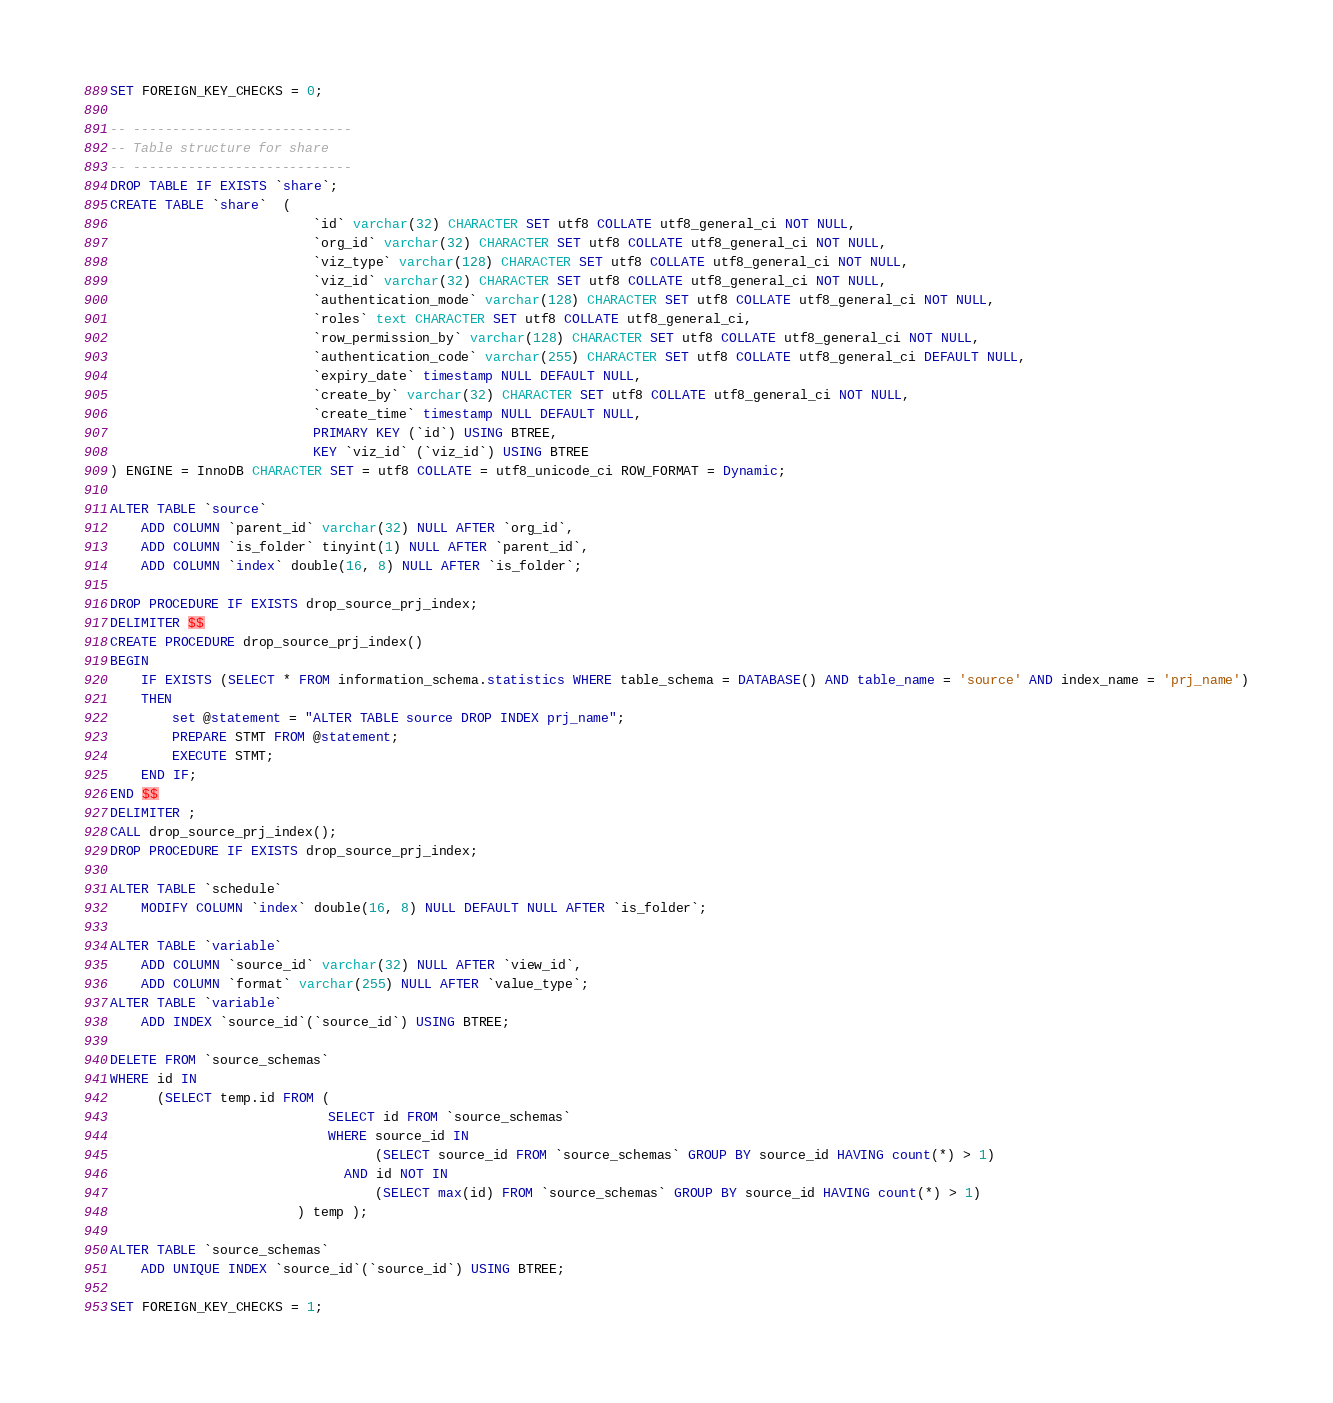<code> <loc_0><loc_0><loc_500><loc_500><_SQL_>SET FOREIGN_KEY_CHECKS = 0;

-- ----------------------------
-- Table structure for share
-- ----------------------------
DROP TABLE IF EXISTS `share`;
CREATE TABLE `share`  (
                          `id` varchar(32) CHARACTER SET utf8 COLLATE utf8_general_ci NOT NULL,
                          `org_id` varchar(32) CHARACTER SET utf8 COLLATE utf8_general_ci NOT NULL,
                          `viz_type` varchar(128) CHARACTER SET utf8 COLLATE utf8_general_ci NOT NULL,
                          `viz_id` varchar(32) CHARACTER SET utf8 COLLATE utf8_general_ci NOT NULL,
                          `authentication_mode` varchar(128) CHARACTER SET utf8 COLLATE utf8_general_ci NOT NULL,
                          `roles` text CHARACTER SET utf8 COLLATE utf8_general_ci,
                          `row_permission_by` varchar(128) CHARACTER SET utf8 COLLATE utf8_general_ci NOT NULL,
                          `authentication_code` varchar(255) CHARACTER SET utf8 COLLATE utf8_general_ci DEFAULT NULL,
                          `expiry_date` timestamp NULL DEFAULT NULL,
                          `create_by` varchar(32) CHARACTER SET utf8 COLLATE utf8_general_ci NOT NULL,
                          `create_time` timestamp NULL DEFAULT NULL,
                          PRIMARY KEY (`id`) USING BTREE,
                          KEY `viz_id` (`viz_id`) USING BTREE
) ENGINE = InnoDB CHARACTER SET = utf8 COLLATE = utf8_unicode_ci ROW_FORMAT = Dynamic;

ALTER TABLE `source`
    ADD COLUMN `parent_id` varchar(32) NULL AFTER `org_id`,
    ADD COLUMN `is_folder` tinyint(1) NULL AFTER `parent_id`,
    ADD COLUMN `index` double(16, 8) NULL AFTER `is_folder`;

DROP PROCEDURE IF EXISTS drop_source_prj_index;
DELIMITER $$
CREATE PROCEDURE drop_source_prj_index()
BEGIN
	IF EXISTS (SELECT * FROM information_schema.statistics WHERE table_schema = DATABASE() AND table_name = 'source' AND index_name = 'prj_name')
	THEN
	    set @statement = "ALTER TABLE source DROP INDEX prj_name";
        PREPARE STMT FROM @statement;
        EXECUTE STMT;
    END IF;
END $$
DELIMITER ;
CALL drop_source_prj_index();
DROP PROCEDURE IF EXISTS drop_source_prj_index;

ALTER TABLE `schedule`
    MODIFY COLUMN `index` double(16, 8) NULL DEFAULT NULL AFTER `is_folder`;

ALTER TABLE `variable`
    ADD COLUMN `source_id` varchar(32) NULL AFTER `view_id`,
    ADD COLUMN `format` varchar(255) NULL AFTER `value_type`;
ALTER TABLE `variable`
    ADD INDEX `source_id`(`source_id`) USING BTREE;

DELETE FROM `source_schemas`
WHERE id IN
      (SELECT temp.id FROM (
                            SELECT id FROM `source_schemas`
                            WHERE source_id IN
                                  (SELECT source_id FROM `source_schemas` GROUP BY source_id HAVING count(*) > 1)
                              AND id NOT IN
                                  (SELECT max(id) FROM `source_schemas` GROUP BY source_id HAVING count(*) > 1)
                        ) temp );

ALTER TABLE `source_schemas`
    ADD UNIQUE INDEX `source_id`(`source_id`) USING BTREE;

SET FOREIGN_KEY_CHECKS = 1;
</code> 